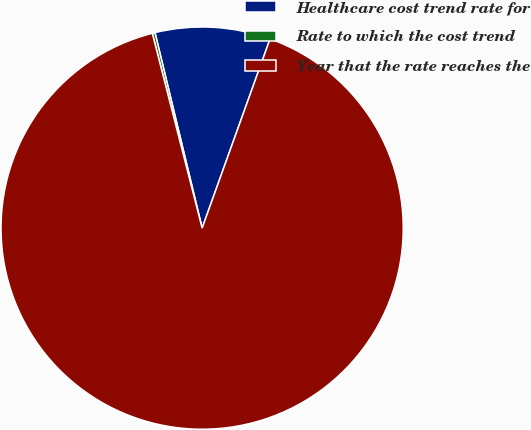Convert chart. <chart><loc_0><loc_0><loc_500><loc_500><pie_chart><fcel>Healthcare cost trend rate for<fcel>Rate to which the cost trend<fcel>Year that the rate reaches the<nl><fcel>9.25%<fcel>0.22%<fcel>90.52%<nl></chart> 